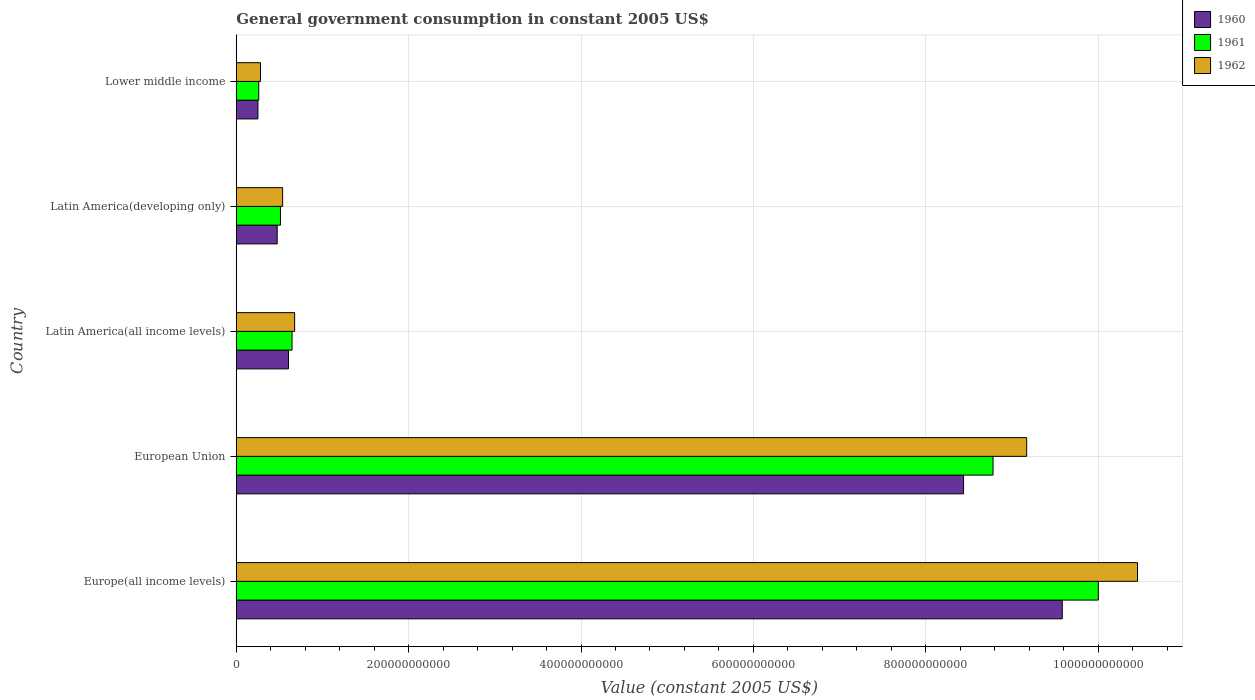How many groups of bars are there?
Give a very brief answer. 5. Are the number of bars per tick equal to the number of legend labels?
Your answer should be compact. Yes. How many bars are there on the 1st tick from the top?
Provide a succinct answer. 3. How many bars are there on the 1st tick from the bottom?
Offer a terse response. 3. What is the label of the 1st group of bars from the top?
Offer a terse response. Lower middle income. What is the government conusmption in 1961 in Latin America(developing only)?
Keep it short and to the point. 5.13e+1. Across all countries, what is the maximum government conusmption in 1962?
Your response must be concise. 1.05e+12. Across all countries, what is the minimum government conusmption in 1962?
Offer a very short reply. 2.81e+1. In which country was the government conusmption in 1960 maximum?
Give a very brief answer. Europe(all income levels). In which country was the government conusmption in 1962 minimum?
Your answer should be compact. Lower middle income. What is the total government conusmption in 1962 in the graph?
Offer a terse response. 2.11e+12. What is the difference between the government conusmption in 1961 in Europe(all income levels) and that in Lower middle income?
Your answer should be very brief. 9.74e+11. What is the difference between the government conusmption in 1961 in European Union and the government conusmption in 1960 in Europe(all income levels)?
Offer a terse response. -8.03e+1. What is the average government conusmption in 1962 per country?
Your response must be concise. 4.22e+11. What is the difference between the government conusmption in 1962 and government conusmption in 1961 in Lower middle income?
Your answer should be compact. 2.00e+09. What is the ratio of the government conusmption in 1960 in Europe(all income levels) to that in Latin America(all income levels)?
Your answer should be compact. 15.82. Is the difference between the government conusmption in 1962 in Europe(all income levels) and Latin America(all income levels) greater than the difference between the government conusmption in 1961 in Europe(all income levels) and Latin America(all income levels)?
Keep it short and to the point. Yes. What is the difference between the highest and the second highest government conusmption in 1962?
Provide a short and direct response. 1.29e+11. What is the difference between the highest and the lowest government conusmption in 1962?
Your answer should be compact. 1.02e+12. In how many countries, is the government conusmption in 1962 greater than the average government conusmption in 1962 taken over all countries?
Your answer should be compact. 2. Are all the bars in the graph horizontal?
Ensure brevity in your answer.  Yes. How many countries are there in the graph?
Ensure brevity in your answer.  5. What is the difference between two consecutive major ticks on the X-axis?
Offer a very short reply. 2.00e+11. Does the graph contain any zero values?
Ensure brevity in your answer.  No. Does the graph contain grids?
Offer a terse response. Yes. How many legend labels are there?
Keep it short and to the point. 3. What is the title of the graph?
Offer a very short reply. General government consumption in constant 2005 US$. What is the label or title of the X-axis?
Your answer should be compact. Value (constant 2005 US$). What is the label or title of the Y-axis?
Give a very brief answer. Country. What is the Value (constant 2005 US$) in 1960 in Europe(all income levels)?
Provide a succinct answer. 9.58e+11. What is the Value (constant 2005 US$) of 1961 in Europe(all income levels)?
Offer a terse response. 1.00e+12. What is the Value (constant 2005 US$) in 1962 in Europe(all income levels)?
Ensure brevity in your answer.  1.05e+12. What is the Value (constant 2005 US$) in 1960 in European Union?
Ensure brevity in your answer.  8.44e+11. What is the Value (constant 2005 US$) in 1961 in European Union?
Provide a short and direct response. 8.78e+11. What is the Value (constant 2005 US$) of 1962 in European Union?
Give a very brief answer. 9.17e+11. What is the Value (constant 2005 US$) of 1960 in Latin America(all income levels)?
Offer a very short reply. 6.06e+1. What is the Value (constant 2005 US$) in 1961 in Latin America(all income levels)?
Your answer should be very brief. 6.47e+1. What is the Value (constant 2005 US$) of 1962 in Latin America(all income levels)?
Your response must be concise. 6.77e+1. What is the Value (constant 2005 US$) of 1960 in Latin America(developing only)?
Offer a terse response. 4.75e+1. What is the Value (constant 2005 US$) of 1961 in Latin America(developing only)?
Give a very brief answer. 5.13e+1. What is the Value (constant 2005 US$) in 1962 in Latin America(developing only)?
Ensure brevity in your answer.  5.38e+1. What is the Value (constant 2005 US$) of 1960 in Lower middle income?
Offer a terse response. 2.52e+1. What is the Value (constant 2005 US$) of 1961 in Lower middle income?
Keep it short and to the point. 2.61e+1. What is the Value (constant 2005 US$) of 1962 in Lower middle income?
Offer a very short reply. 2.81e+1. Across all countries, what is the maximum Value (constant 2005 US$) of 1960?
Keep it short and to the point. 9.58e+11. Across all countries, what is the maximum Value (constant 2005 US$) in 1961?
Your answer should be compact. 1.00e+12. Across all countries, what is the maximum Value (constant 2005 US$) of 1962?
Your answer should be very brief. 1.05e+12. Across all countries, what is the minimum Value (constant 2005 US$) in 1960?
Your answer should be very brief. 2.52e+1. Across all countries, what is the minimum Value (constant 2005 US$) in 1961?
Provide a short and direct response. 2.61e+1. Across all countries, what is the minimum Value (constant 2005 US$) of 1962?
Your answer should be compact. 2.81e+1. What is the total Value (constant 2005 US$) of 1960 in the graph?
Give a very brief answer. 1.94e+12. What is the total Value (constant 2005 US$) in 1961 in the graph?
Ensure brevity in your answer.  2.02e+12. What is the total Value (constant 2005 US$) of 1962 in the graph?
Keep it short and to the point. 2.11e+12. What is the difference between the Value (constant 2005 US$) in 1960 in Europe(all income levels) and that in European Union?
Make the answer very short. 1.15e+11. What is the difference between the Value (constant 2005 US$) in 1961 in Europe(all income levels) and that in European Union?
Ensure brevity in your answer.  1.22e+11. What is the difference between the Value (constant 2005 US$) in 1962 in Europe(all income levels) and that in European Union?
Keep it short and to the point. 1.29e+11. What is the difference between the Value (constant 2005 US$) of 1960 in Europe(all income levels) and that in Latin America(all income levels)?
Keep it short and to the point. 8.98e+11. What is the difference between the Value (constant 2005 US$) in 1961 in Europe(all income levels) and that in Latin America(all income levels)?
Ensure brevity in your answer.  9.35e+11. What is the difference between the Value (constant 2005 US$) in 1962 in Europe(all income levels) and that in Latin America(all income levels)?
Offer a very short reply. 9.78e+11. What is the difference between the Value (constant 2005 US$) of 1960 in Europe(all income levels) and that in Latin America(developing only)?
Your answer should be compact. 9.11e+11. What is the difference between the Value (constant 2005 US$) in 1961 in Europe(all income levels) and that in Latin America(developing only)?
Your answer should be very brief. 9.49e+11. What is the difference between the Value (constant 2005 US$) in 1962 in Europe(all income levels) and that in Latin America(developing only)?
Offer a terse response. 9.92e+11. What is the difference between the Value (constant 2005 US$) in 1960 in Europe(all income levels) and that in Lower middle income?
Provide a succinct answer. 9.33e+11. What is the difference between the Value (constant 2005 US$) of 1961 in Europe(all income levels) and that in Lower middle income?
Offer a very short reply. 9.74e+11. What is the difference between the Value (constant 2005 US$) of 1962 in Europe(all income levels) and that in Lower middle income?
Your answer should be compact. 1.02e+12. What is the difference between the Value (constant 2005 US$) in 1960 in European Union and that in Latin America(all income levels)?
Give a very brief answer. 7.83e+11. What is the difference between the Value (constant 2005 US$) of 1961 in European Union and that in Latin America(all income levels)?
Provide a succinct answer. 8.13e+11. What is the difference between the Value (constant 2005 US$) of 1962 in European Union and that in Latin America(all income levels)?
Give a very brief answer. 8.49e+11. What is the difference between the Value (constant 2005 US$) in 1960 in European Union and that in Latin America(developing only)?
Make the answer very short. 7.96e+11. What is the difference between the Value (constant 2005 US$) of 1961 in European Union and that in Latin America(developing only)?
Keep it short and to the point. 8.27e+11. What is the difference between the Value (constant 2005 US$) of 1962 in European Union and that in Latin America(developing only)?
Your answer should be very brief. 8.63e+11. What is the difference between the Value (constant 2005 US$) in 1960 in European Union and that in Lower middle income?
Provide a succinct answer. 8.19e+11. What is the difference between the Value (constant 2005 US$) in 1961 in European Union and that in Lower middle income?
Ensure brevity in your answer.  8.52e+11. What is the difference between the Value (constant 2005 US$) in 1962 in European Union and that in Lower middle income?
Provide a succinct answer. 8.89e+11. What is the difference between the Value (constant 2005 US$) of 1960 in Latin America(all income levels) and that in Latin America(developing only)?
Ensure brevity in your answer.  1.31e+1. What is the difference between the Value (constant 2005 US$) of 1961 in Latin America(all income levels) and that in Latin America(developing only)?
Give a very brief answer. 1.35e+1. What is the difference between the Value (constant 2005 US$) in 1962 in Latin America(all income levels) and that in Latin America(developing only)?
Provide a succinct answer. 1.39e+1. What is the difference between the Value (constant 2005 US$) in 1960 in Latin America(all income levels) and that in Lower middle income?
Your answer should be very brief. 3.54e+1. What is the difference between the Value (constant 2005 US$) in 1961 in Latin America(all income levels) and that in Lower middle income?
Offer a very short reply. 3.86e+1. What is the difference between the Value (constant 2005 US$) in 1962 in Latin America(all income levels) and that in Lower middle income?
Offer a terse response. 3.96e+1. What is the difference between the Value (constant 2005 US$) of 1960 in Latin America(developing only) and that in Lower middle income?
Your answer should be very brief. 2.23e+1. What is the difference between the Value (constant 2005 US$) of 1961 in Latin America(developing only) and that in Lower middle income?
Provide a short and direct response. 2.52e+1. What is the difference between the Value (constant 2005 US$) in 1962 in Latin America(developing only) and that in Lower middle income?
Offer a very short reply. 2.57e+1. What is the difference between the Value (constant 2005 US$) of 1960 in Europe(all income levels) and the Value (constant 2005 US$) of 1961 in European Union?
Your response must be concise. 8.03e+1. What is the difference between the Value (constant 2005 US$) in 1960 in Europe(all income levels) and the Value (constant 2005 US$) in 1962 in European Union?
Offer a terse response. 4.13e+1. What is the difference between the Value (constant 2005 US$) of 1961 in Europe(all income levels) and the Value (constant 2005 US$) of 1962 in European Union?
Your answer should be compact. 8.31e+1. What is the difference between the Value (constant 2005 US$) of 1960 in Europe(all income levels) and the Value (constant 2005 US$) of 1961 in Latin America(all income levels)?
Offer a very short reply. 8.94e+11. What is the difference between the Value (constant 2005 US$) in 1960 in Europe(all income levels) and the Value (constant 2005 US$) in 1962 in Latin America(all income levels)?
Ensure brevity in your answer.  8.91e+11. What is the difference between the Value (constant 2005 US$) in 1961 in Europe(all income levels) and the Value (constant 2005 US$) in 1962 in Latin America(all income levels)?
Keep it short and to the point. 9.32e+11. What is the difference between the Value (constant 2005 US$) in 1960 in Europe(all income levels) and the Value (constant 2005 US$) in 1961 in Latin America(developing only)?
Offer a terse response. 9.07e+11. What is the difference between the Value (constant 2005 US$) in 1960 in Europe(all income levels) and the Value (constant 2005 US$) in 1962 in Latin America(developing only)?
Provide a short and direct response. 9.05e+11. What is the difference between the Value (constant 2005 US$) of 1961 in Europe(all income levels) and the Value (constant 2005 US$) of 1962 in Latin America(developing only)?
Give a very brief answer. 9.46e+11. What is the difference between the Value (constant 2005 US$) of 1960 in Europe(all income levels) and the Value (constant 2005 US$) of 1961 in Lower middle income?
Ensure brevity in your answer.  9.32e+11. What is the difference between the Value (constant 2005 US$) of 1960 in Europe(all income levels) and the Value (constant 2005 US$) of 1962 in Lower middle income?
Provide a short and direct response. 9.30e+11. What is the difference between the Value (constant 2005 US$) in 1961 in Europe(all income levels) and the Value (constant 2005 US$) in 1962 in Lower middle income?
Your response must be concise. 9.72e+11. What is the difference between the Value (constant 2005 US$) of 1960 in European Union and the Value (constant 2005 US$) of 1961 in Latin America(all income levels)?
Your answer should be compact. 7.79e+11. What is the difference between the Value (constant 2005 US$) in 1960 in European Union and the Value (constant 2005 US$) in 1962 in Latin America(all income levels)?
Provide a short and direct response. 7.76e+11. What is the difference between the Value (constant 2005 US$) in 1961 in European Union and the Value (constant 2005 US$) in 1962 in Latin America(all income levels)?
Ensure brevity in your answer.  8.10e+11. What is the difference between the Value (constant 2005 US$) of 1960 in European Union and the Value (constant 2005 US$) of 1961 in Latin America(developing only)?
Your answer should be very brief. 7.93e+11. What is the difference between the Value (constant 2005 US$) of 1960 in European Union and the Value (constant 2005 US$) of 1962 in Latin America(developing only)?
Your response must be concise. 7.90e+11. What is the difference between the Value (constant 2005 US$) in 1961 in European Union and the Value (constant 2005 US$) in 1962 in Latin America(developing only)?
Keep it short and to the point. 8.24e+11. What is the difference between the Value (constant 2005 US$) in 1960 in European Union and the Value (constant 2005 US$) in 1961 in Lower middle income?
Give a very brief answer. 8.18e+11. What is the difference between the Value (constant 2005 US$) in 1960 in European Union and the Value (constant 2005 US$) in 1962 in Lower middle income?
Offer a terse response. 8.16e+11. What is the difference between the Value (constant 2005 US$) in 1961 in European Union and the Value (constant 2005 US$) in 1962 in Lower middle income?
Your answer should be compact. 8.50e+11. What is the difference between the Value (constant 2005 US$) of 1960 in Latin America(all income levels) and the Value (constant 2005 US$) of 1961 in Latin America(developing only)?
Offer a terse response. 9.29e+09. What is the difference between the Value (constant 2005 US$) in 1960 in Latin America(all income levels) and the Value (constant 2005 US$) in 1962 in Latin America(developing only)?
Give a very brief answer. 6.76e+09. What is the difference between the Value (constant 2005 US$) of 1961 in Latin America(all income levels) and the Value (constant 2005 US$) of 1962 in Latin America(developing only)?
Your answer should be compact. 1.09e+1. What is the difference between the Value (constant 2005 US$) of 1960 in Latin America(all income levels) and the Value (constant 2005 US$) of 1961 in Lower middle income?
Offer a terse response. 3.45e+1. What is the difference between the Value (constant 2005 US$) of 1960 in Latin America(all income levels) and the Value (constant 2005 US$) of 1962 in Lower middle income?
Offer a terse response. 3.25e+1. What is the difference between the Value (constant 2005 US$) of 1961 in Latin America(all income levels) and the Value (constant 2005 US$) of 1962 in Lower middle income?
Your response must be concise. 3.66e+1. What is the difference between the Value (constant 2005 US$) of 1960 in Latin America(developing only) and the Value (constant 2005 US$) of 1961 in Lower middle income?
Your response must be concise. 2.14e+1. What is the difference between the Value (constant 2005 US$) in 1960 in Latin America(developing only) and the Value (constant 2005 US$) in 1962 in Lower middle income?
Give a very brief answer. 1.94e+1. What is the difference between the Value (constant 2005 US$) of 1961 in Latin America(developing only) and the Value (constant 2005 US$) of 1962 in Lower middle income?
Give a very brief answer. 2.32e+1. What is the average Value (constant 2005 US$) of 1960 per country?
Offer a terse response. 3.87e+11. What is the average Value (constant 2005 US$) of 1961 per country?
Offer a terse response. 4.04e+11. What is the average Value (constant 2005 US$) of 1962 per country?
Give a very brief answer. 4.22e+11. What is the difference between the Value (constant 2005 US$) in 1960 and Value (constant 2005 US$) in 1961 in Europe(all income levels)?
Keep it short and to the point. -4.18e+1. What is the difference between the Value (constant 2005 US$) of 1960 and Value (constant 2005 US$) of 1962 in Europe(all income levels)?
Your answer should be very brief. -8.73e+1. What is the difference between the Value (constant 2005 US$) in 1961 and Value (constant 2005 US$) in 1962 in Europe(all income levels)?
Provide a short and direct response. -4.54e+1. What is the difference between the Value (constant 2005 US$) in 1960 and Value (constant 2005 US$) in 1961 in European Union?
Your answer should be compact. -3.42e+1. What is the difference between the Value (constant 2005 US$) in 1960 and Value (constant 2005 US$) in 1962 in European Union?
Offer a terse response. -7.32e+1. What is the difference between the Value (constant 2005 US$) of 1961 and Value (constant 2005 US$) of 1962 in European Union?
Your response must be concise. -3.90e+1. What is the difference between the Value (constant 2005 US$) in 1960 and Value (constant 2005 US$) in 1961 in Latin America(all income levels)?
Your answer should be compact. -4.16e+09. What is the difference between the Value (constant 2005 US$) in 1960 and Value (constant 2005 US$) in 1962 in Latin America(all income levels)?
Give a very brief answer. -7.17e+09. What is the difference between the Value (constant 2005 US$) of 1961 and Value (constant 2005 US$) of 1962 in Latin America(all income levels)?
Offer a terse response. -3.01e+09. What is the difference between the Value (constant 2005 US$) of 1960 and Value (constant 2005 US$) of 1961 in Latin America(developing only)?
Provide a succinct answer. -3.79e+09. What is the difference between the Value (constant 2005 US$) in 1960 and Value (constant 2005 US$) in 1962 in Latin America(developing only)?
Provide a succinct answer. -6.32e+09. What is the difference between the Value (constant 2005 US$) in 1961 and Value (constant 2005 US$) in 1962 in Latin America(developing only)?
Offer a terse response. -2.53e+09. What is the difference between the Value (constant 2005 US$) of 1960 and Value (constant 2005 US$) of 1961 in Lower middle income?
Ensure brevity in your answer.  -9.46e+08. What is the difference between the Value (constant 2005 US$) of 1960 and Value (constant 2005 US$) of 1962 in Lower middle income?
Keep it short and to the point. -2.95e+09. What is the difference between the Value (constant 2005 US$) in 1961 and Value (constant 2005 US$) in 1962 in Lower middle income?
Give a very brief answer. -2.00e+09. What is the ratio of the Value (constant 2005 US$) in 1960 in Europe(all income levels) to that in European Union?
Ensure brevity in your answer.  1.14. What is the ratio of the Value (constant 2005 US$) of 1961 in Europe(all income levels) to that in European Union?
Offer a very short reply. 1.14. What is the ratio of the Value (constant 2005 US$) of 1962 in Europe(all income levels) to that in European Union?
Make the answer very short. 1.14. What is the ratio of the Value (constant 2005 US$) of 1960 in Europe(all income levels) to that in Latin America(all income levels)?
Provide a succinct answer. 15.82. What is the ratio of the Value (constant 2005 US$) of 1961 in Europe(all income levels) to that in Latin America(all income levels)?
Your answer should be compact. 15.45. What is the ratio of the Value (constant 2005 US$) of 1962 in Europe(all income levels) to that in Latin America(all income levels)?
Make the answer very short. 15.43. What is the ratio of the Value (constant 2005 US$) of 1960 in Europe(all income levels) to that in Latin America(developing only)?
Make the answer very short. 20.18. What is the ratio of the Value (constant 2005 US$) in 1961 in Europe(all income levels) to that in Latin America(developing only)?
Provide a succinct answer. 19.5. What is the ratio of the Value (constant 2005 US$) in 1962 in Europe(all income levels) to that in Latin America(developing only)?
Give a very brief answer. 19.43. What is the ratio of the Value (constant 2005 US$) of 1960 in Europe(all income levels) to that in Lower middle income?
Give a very brief answer. 38.07. What is the ratio of the Value (constant 2005 US$) of 1961 in Europe(all income levels) to that in Lower middle income?
Offer a terse response. 38.29. What is the ratio of the Value (constant 2005 US$) in 1962 in Europe(all income levels) to that in Lower middle income?
Ensure brevity in your answer.  37.18. What is the ratio of the Value (constant 2005 US$) in 1960 in European Union to that in Latin America(all income levels)?
Keep it short and to the point. 13.93. What is the ratio of the Value (constant 2005 US$) of 1961 in European Union to that in Latin America(all income levels)?
Make the answer very short. 13.56. What is the ratio of the Value (constant 2005 US$) of 1962 in European Union to that in Latin America(all income levels)?
Provide a short and direct response. 13.54. What is the ratio of the Value (constant 2005 US$) of 1960 in European Union to that in Latin America(developing only)?
Offer a terse response. 17.77. What is the ratio of the Value (constant 2005 US$) of 1961 in European Union to that in Latin America(developing only)?
Make the answer very short. 17.12. What is the ratio of the Value (constant 2005 US$) in 1962 in European Union to that in Latin America(developing only)?
Your answer should be compact. 17.04. What is the ratio of the Value (constant 2005 US$) in 1960 in European Union to that in Lower middle income?
Offer a terse response. 33.52. What is the ratio of the Value (constant 2005 US$) of 1961 in European Union to that in Lower middle income?
Offer a terse response. 33.61. What is the ratio of the Value (constant 2005 US$) in 1962 in European Union to that in Lower middle income?
Provide a succinct answer. 32.61. What is the ratio of the Value (constant 2005 US$) of 1960 in Latin America(all income levels) to that in Latin America(developing only)?
Your answer should be compact. 1.28. What is the ratio of the Value (constant 2005 US$) in 1961 in Latin America(all income levels) to that in Latin America(developing only)?
Offer a terse response. 1.26. What is the ratio of the Value (constant 2005 US$) in 1962 in Latin America(all income levels) to that in Latin America(developing only)?
Provide a short and direct response. 1.26. What is the ratio of the Value (constant 2005 US$) in 1960 in Latin America(all income levels) to that in Lower middle income?
Your answer should be very brief. 2.41. What is the ratio of the Value (constant 2005 US$) of 1961 in Latin America(all income levels) to that in Lower middle income?
Keep it short and to the point. 2.48. What is the ratio of the Value (constant 2005 US$) of 1962 in Latin America(all income levels) to that in Lower middle income?
Your answer should be compact. 2.41. What is the ratio of the Value (constant 2005 US$) of 1960 in Latin America(developing only) to that in Lower middle income?
Keep it short and to the point. 1.89. What is the ratio of the Value (constant 2005 US$) of 1961 in Latin America(developing only) to that in Lower middle income?
Your answer should be very brief. 1.96. What is the ratio of the Value (constant 2005 US$) of 1962 in Latin America(developing only) to that in Lower middle income?
Ensure brevity in your answer.  1.91. What is the difference between the highest and the second highest Value (constant 2005 US$) in 1960?
Give a very brief answer. 1.15e+11. What is the difference between the highest and the second highest Value (constant 2005 US$) of 1961?
Keep it short and to the point. 1.22e+11. What is the difference between the highest and the second highest Value (constant 2005 US$) of 1962?
Provide a short and direct response. 1.29e+11. What is the difference between the highest and the lowest Value (constant 2005 US$) in 1960?
Give a very brief answer. 9.33e+11. What is the difference between the highest and the lowest Value (constant 2005 US$) of 1961?
Provide a short and direct response. 9.74e+11. What is the difference between the highest and the lowest Value (constant 2005 US$) of 1962?
Make the answer very short. 1.02e+12. 